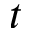Convert formula to latex. <formula><loc_0><loc_0><loc_500><loc_500>t</formula> 